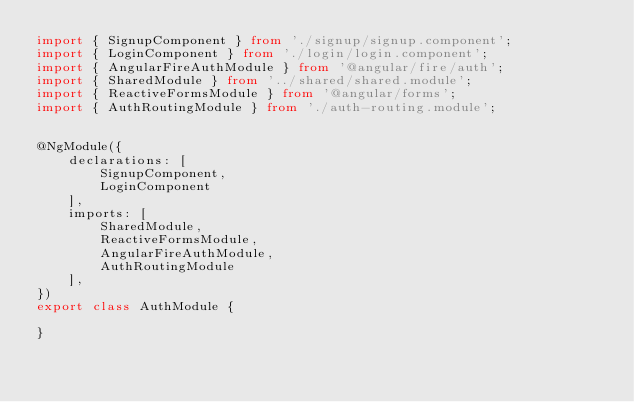Convert code to text. <code><loc_0><loc_0><loc_500><loc_500><_TypeScript_>import { SignupComponent } from './signup/signup.component';
import { LoginComponent } from './login/login.component';
import { AngularFireAuthModule } from '@angular/fire/auth';
import { SharedModule } from '../shared/shared.module';
import { ReactiveFormsModule } from '@angular/forms';
import { AuthRoutingModule } from './auth-routing.module';


@NgModule({
    declarations: [
        SignupComponent,
        LoginComponent
    ],
    imports: [
        SharedModule,
        ReactiveFormsModule,
        AngularFireAuthModule,
        AuthRoutingModule
    ],
})
export class AuthModule {

}</code> 